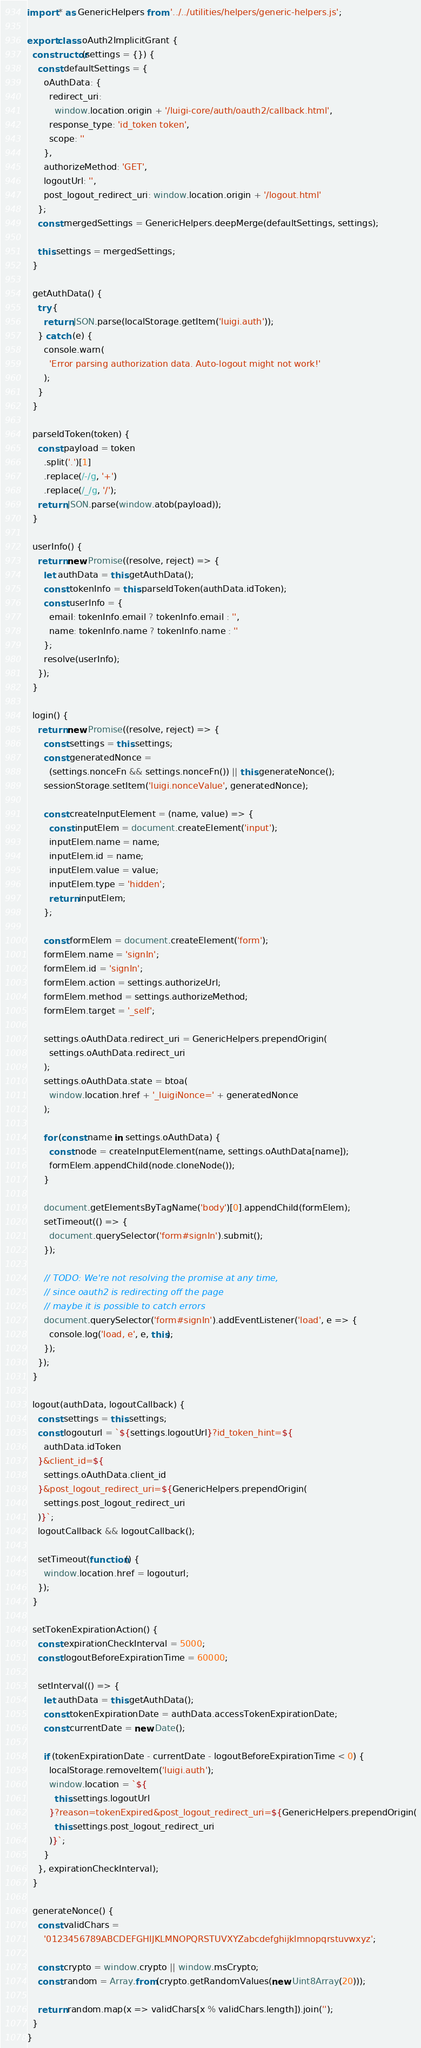Convert code to text. <code><loc_0><loc_0><loc_500><loc_500><_JavaScript_>import * as GenericHelpers from '../../utilities/helpers/generic-helpers.js';

export class oAuth2ImplicitGrant {
  constructor(settings = {}) {
    const defaultSettings = {
      oAuthData: {
        redirect_uri:
          window.location.origin + '/luigi-core/auth/oauth2/callback.html',
        response_type: 'id_token token',
        scope: ''
      },
      authorizeMethod: 'GET',
      logoutUrl: '',
      post_logout_redirect_uri: window.location.origin + '/logout.html'
    };
    const mergedSettings = GenericHelpers.deepMerge(defaultSettings, settings);

    this.settings = mergedSettings;
  }

  getAuthData() {
    try {
      return JSON.parse(localStorage.getItem('luigi.auth'));
    } catch (e) {
      console.warn(
        'Error parsing authorization data. Auto-logout might not work!'
      );
    }
  }

  parseIdToken(token) {
    const payload = token
      .split('.')[1]
      .replace(/-/g, '+')
      .replace(/_/g, '/');
    return JSON.parse(window.atob(payload));
  }

  userInfo() {
    return new Promise((resolve, reject) => {
      let authData = this.getAuthData();
      const tokenInfo = this.parseIdToken(authData.idToken);
      const userInfo = {
        email: tokenInfo.email ? tokenInfo.email : '',
        name: tokenInfo.name ? tokenInfo.name : ''
      };
      resolve(userInfo);
    });
  }

  login() {
    return new Promise((resolve, reject) => {
      const settings = this.settings;
      const generatedNonce =
        (settings.nonceFn && settings.nonceFn()) || this.generateNonce();
      sessionStorage.setItem('luigi.nonceValue', generatedNonce);

      const createInputElement = (name, value) => {
        const inputElem = document.createElement('input');
        inputElem.name = name;
        inputElem.id = name;
        inputElem.value = value;
        inputElem.type = 'hidden';
        return inputElem;
      };

      const formElem = document.createElement('form');
      formElem.name = 'signIn';
      formElem.id = 'signIn';
      formElem.action = settings.authorizeUrl;
      formElem.method = settings.authorizeMethod;
      formElem.target = '_self';

      settings.oAuthData.redirect_uri = GenericHelpers.prependOrigin(
        settings.oAuthData.redirect_uri
      );
      settings.oAuthData.state = btoa(
        window.location.href + '_luigiNonce=' + generatedNonce
      );

      for (const name in settings.oAuthData) {
        const node = createInputElement(name, settings.oAuthData[name]);
        formElem.appendChild(node.cloneNode());
      }

      document.getElementsByTagName('body')[0].appendChild(formElem);
      setTimeout(() => {
        document.querySelector('form#signIn').submit();
      });

      // TODO: We're not resolving the promise at any time,
      // since oauth2 is redirecting off the page
      // maybe it is possible to catch errors
      document.querySelector('form#signIn').addEventListener('load', e => {
        console.log('load, e', e, this);
      });
    });
  }

  logout(authData, logoutCallback) {
    const settings = this.settings;
    const logouturl = `${settings.logoutUrl}?id_token_hint=${
      authData.idToken
    }&client_id=${
      settings.oAuthData.client_id
    }&post_logout_redirect_uri=${GenericHelpers.prependOrigin(
      settings.post_logout_redirect_uri
    )}`;
    logoutCallback && logoutCallback();

    setTimeout(function() {
      window.location.href = logouturl;
    });
  }

  setTokenExpirationAction() {
    const expirationCheckInterval = 5000;
    const logoutBeforeExpirationTime = 60000;

    setInterval(() => {
      let authData = this.getAuthData();
      const tokenExpirationDate = authData.accessTokenExpirationDate;
      const currentDate = new Date();

      if (tokenExpirationDate - currentDate - logoutBeforeExpirationTime < 0) {
        localStorage.removeItem('luigi.auth');
        window.location = `${
          this.settings.logoutUrl
        }?reason=tokenExpired&post_logout_redirect_uri=${GenericHelpers.prependOrigin(
          this.settings.post_logout_redirect_uri
        )}`;
      }
    }, expirationCheckInterval);
  }

  generateNonce() {
    const validChars =
      '0123456789ABCDEFGHIJKLMNOPQRSTUVXYZabcdefghijklmnopqrstuvwxyz';

    const crypto = window.crypto || window.msCrypto;
    const random = Array.from(crypto.getRandomValues(new Uint8Array(20)));

    return random.map(x => validChars[x % validChars.length]).join('');
  }
}
</code> 